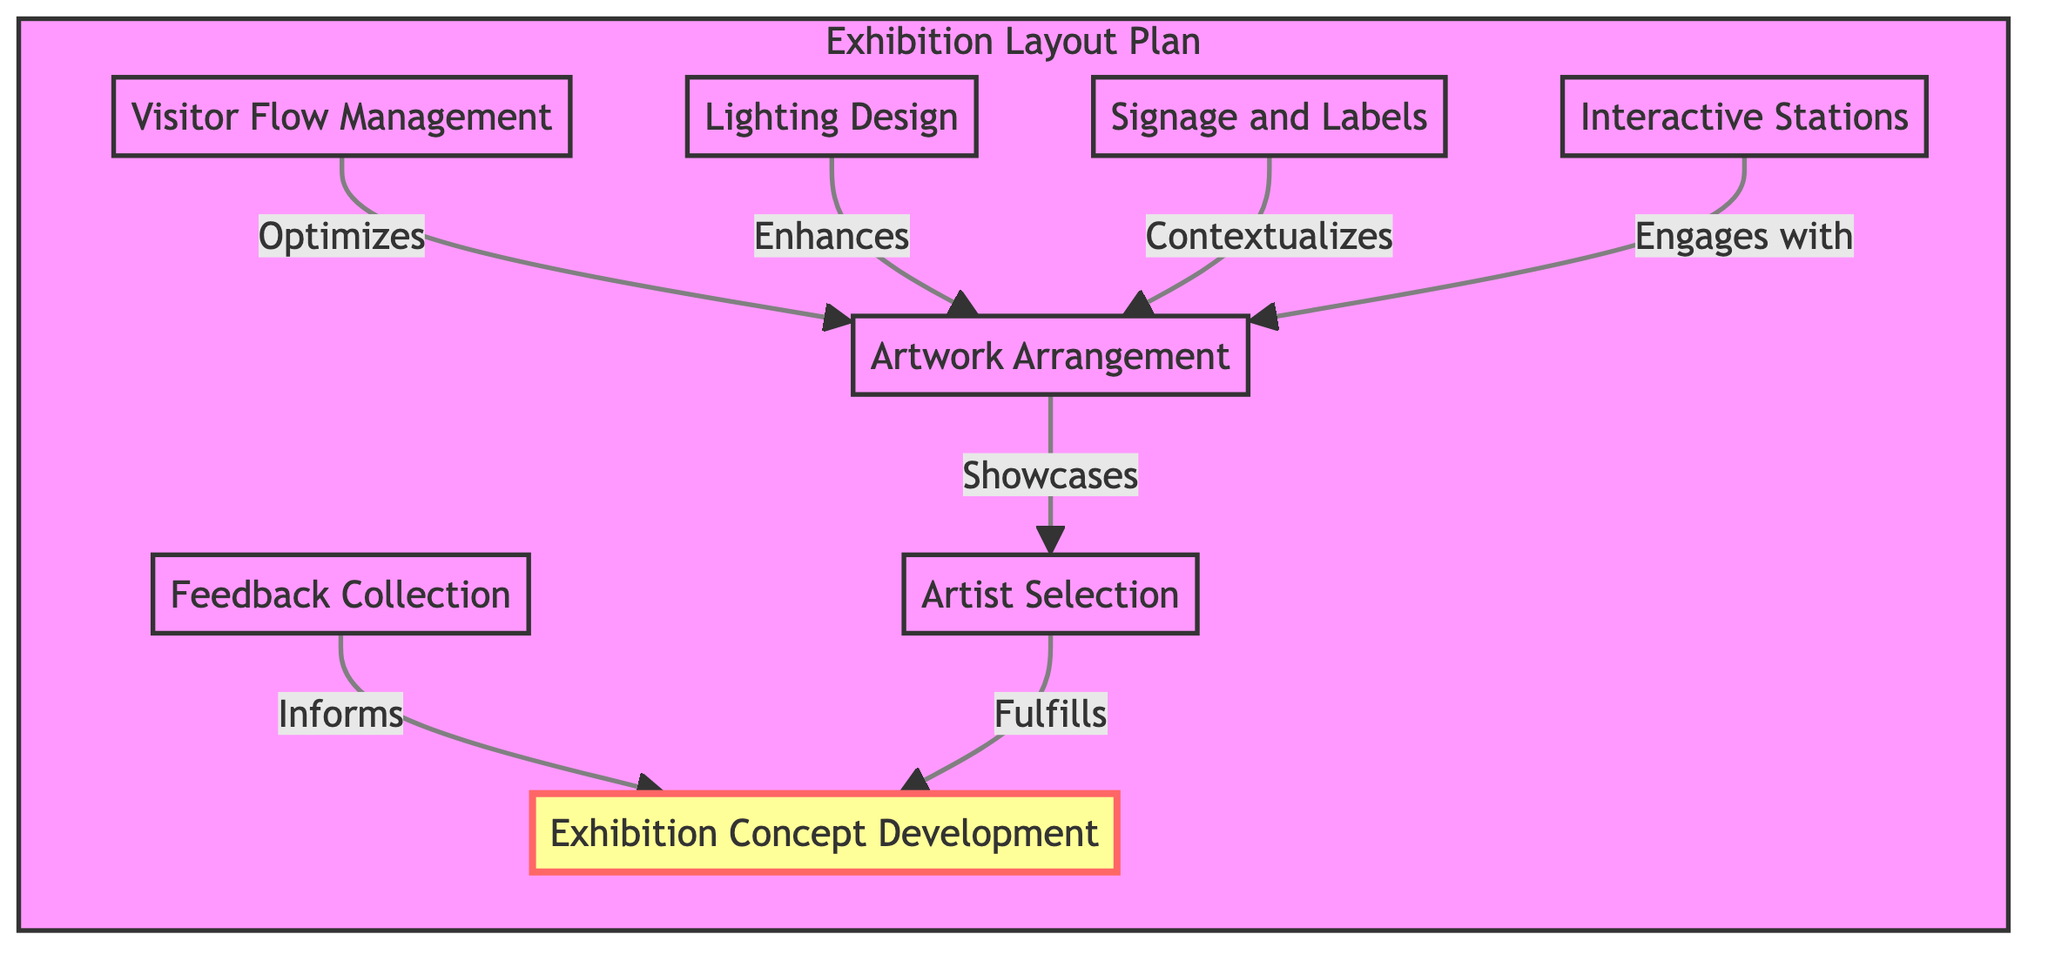What is the first step in the exhibition layout plan? The first step in the exhibition layout plan is labeled as "Exhibition Concept Development," which sets the theme for the entire exhibition.
Answer: Exhibition Concept Development How many main elements are included in the diagram? By counting the elements in the diagram, there are a total of eight nodes: Feedback Collection, Visitor Flow Management, Lighting Design, Signage and Labels, Interactive Stations, Artwork Arrangement, Artist Selection, and Exhibition Concept Development.
Answer: Eight Which element informs the exhibition concept development? The arrow pointing from "Feedback Collection" to "Exhibition Concept Development" shows that feedback from visitors informs how the exhibition concept is developed.
Answer: Feedback Collection What does visitor flow management optimize? The diagram indicates that "Visitor Flow Management" optimizes "Artwork Arrangement," enhancing the movement and experience for visitors through the exhibition.
Answer: Artwork Arrangement Which elements engage with the artwork arrangement? The diagram lists four elements that engage with "Artwork Arrangement": "Interactive Stations," "Lighting Design," "Signage and Labels," and "Visitor Flow Management." These elements all contribute to how artworks are arranged and perceived by visitors.
Answer: Interactive Stations, Lighting Design, Signage and Labels, Visitor Flow Management How does lighting design affect artwork arrangement? The arrow from "Lighting Design" to "Artwork Arrangement" indicates that lighting design enhances the artwork arrangement, making key pieces more visible and contributing to the immersive atmosphere.
Answer: Enhances What role does artist selection play in the exhibition layout plan? According to the diagram, "Artist Selection" is a step that follows "Artwork Arrangement," fulfilling the exhibition concept development by showcasing the chosen artists' works.
Answer: Fulfills What is the final output related to visitor interaction? The flow suggests that after the interactive stations and feedback collection, the final emphasis should be on how the exhibition concept develops further based on visitor engagement, but the exact terminal node for output isn't specified. Thus, the last interaction point is "Feedback Collection."
Answer: Feedback Collection 